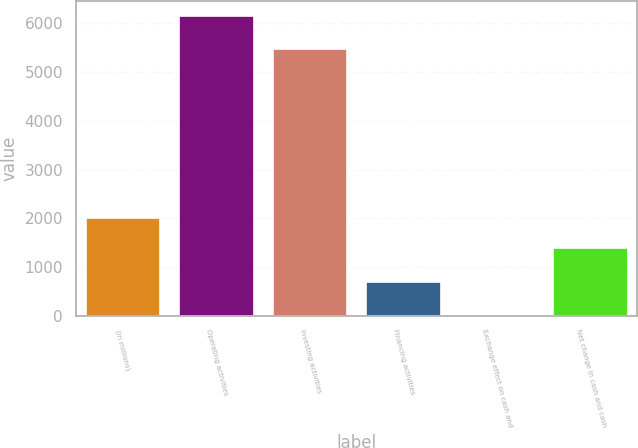Convert chart to OTSL. <chart><loc_0><loc_0><loc_500><loc_500><bar_chart><fcel>(In millions)<fcel>Operating activities<fcel>Investing activities<fcel>Financing activities<fcel>Exchange effect on cash and<fcel>Net change in cash and cash<nl><fcel>2009<fcel>6161<fcel>5476<fcel>699<fcel>2<fcel>1382<nl></chart> 